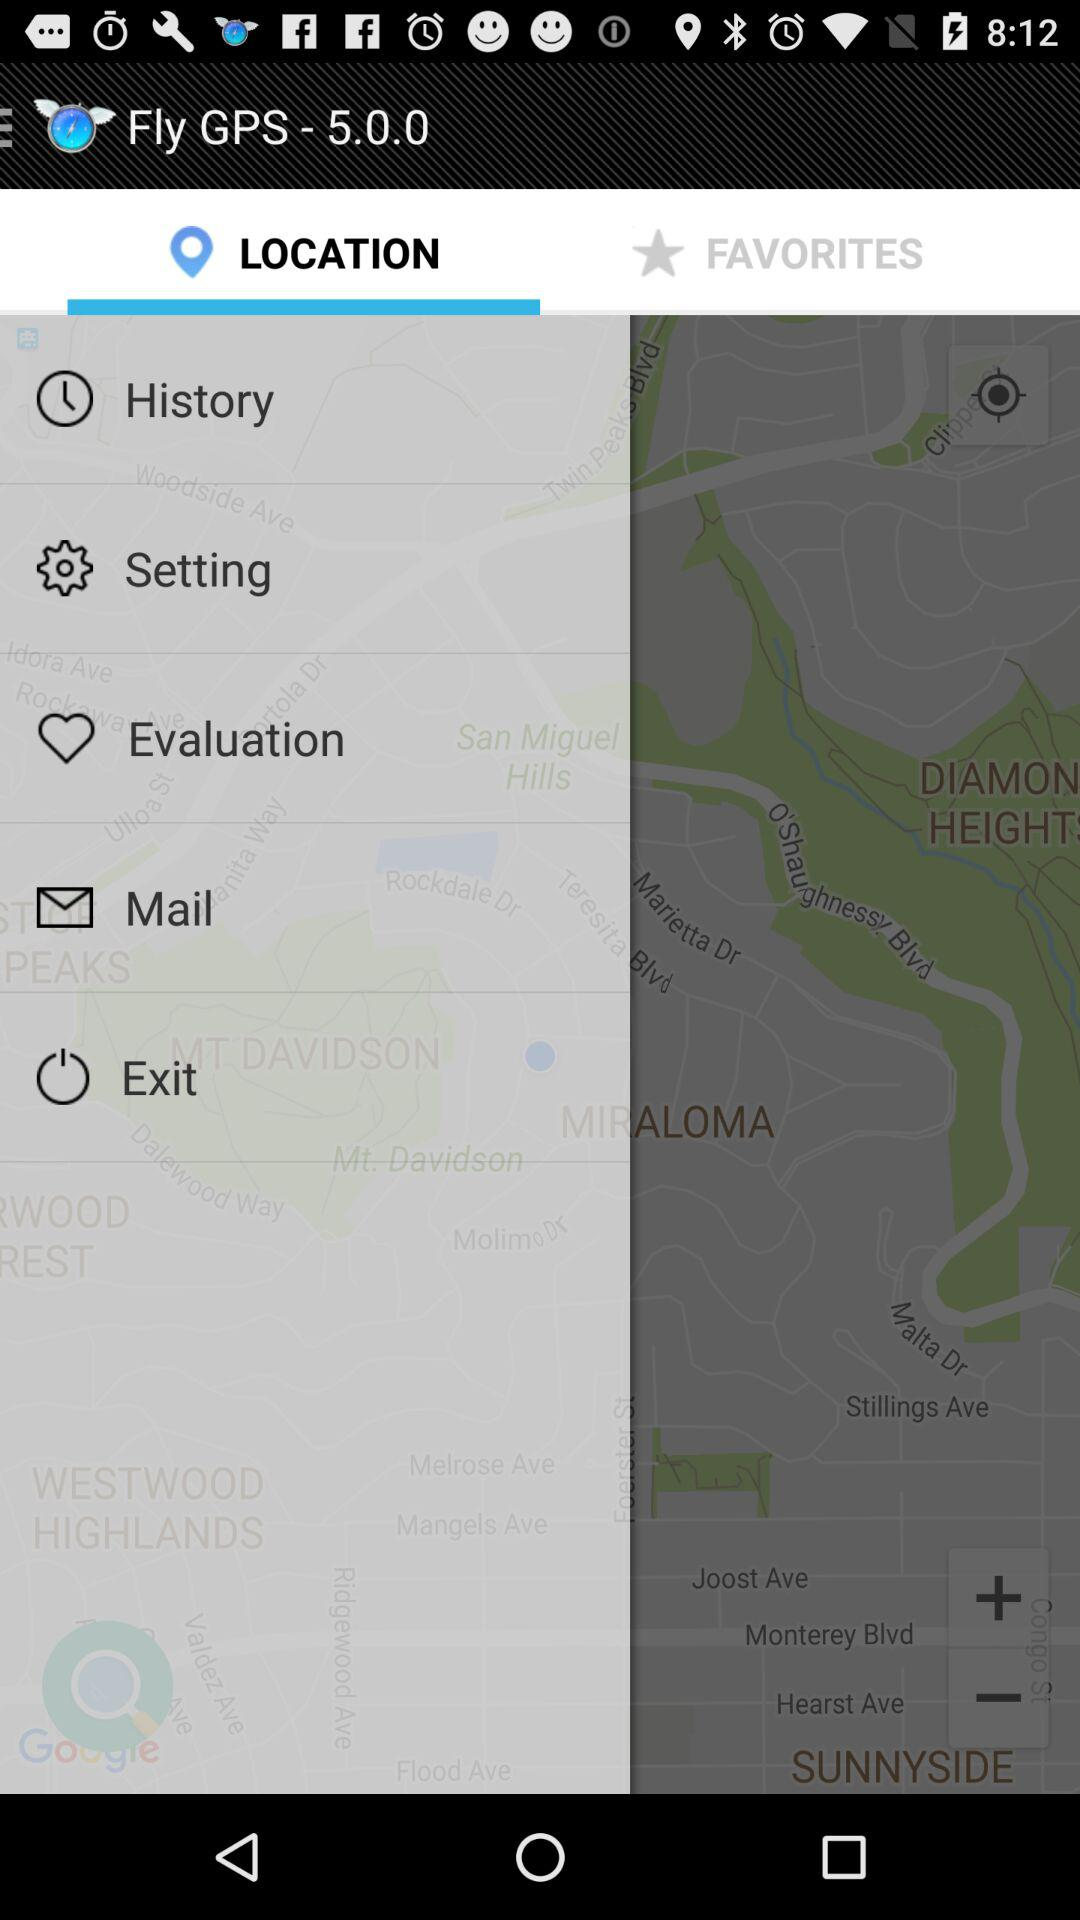Which tab is selected? The selected tab is "LOCATION". 